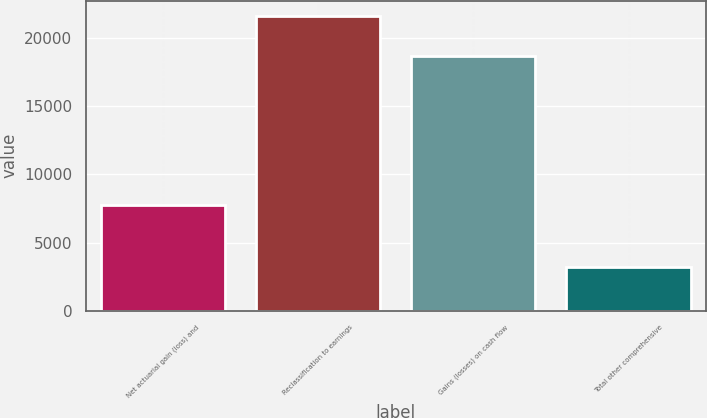<chart> <loc_0><loc_0><loc_500><loc_500><bar_chart><fcel>Net actuarial gain (loss) and<fcel>Reclassification to earnings<fcel>Gains (losses) on cash flow<fcel>Total other comprehensive<nl><fcel>7776<fcel>21653<fcel>18701<fcel>3204<nl></chart> 